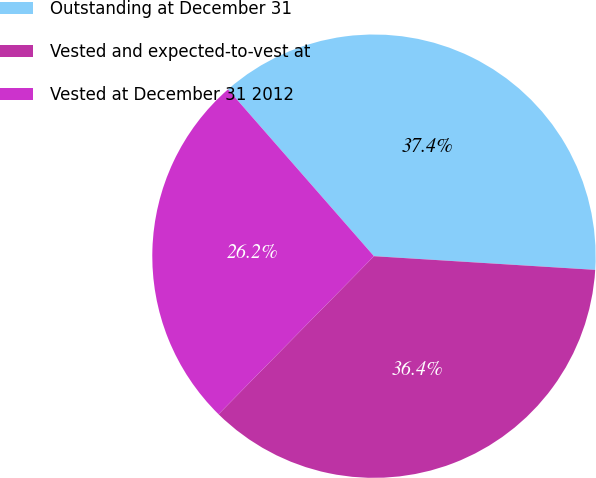Convert chart to OTSL. <chart><loc_0><loc_0><loc_500><loc_500><pie_chart><fcel>Outstanding at December 31<fcel>Vested and expected-to-vest at<fcel>Vested at December 31 2012<nl><fcel>37.42%<fcel>36.38%<fcel>26.19%<nl></chart> 